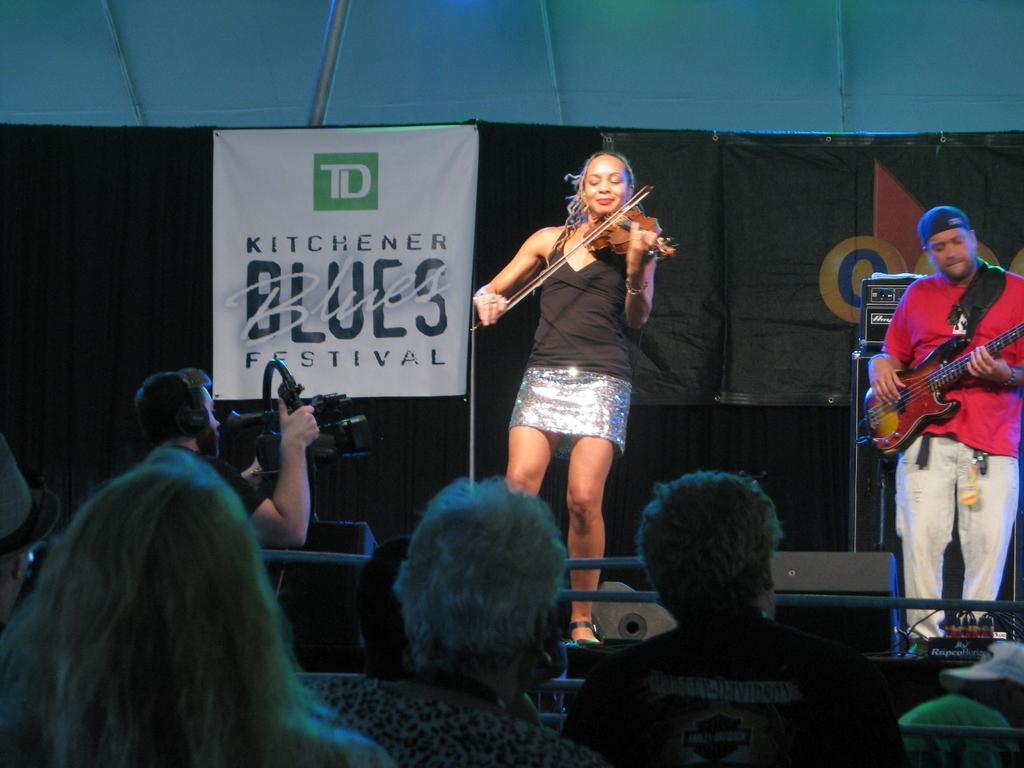Please provide a concise description of this image. In this image I can see two people are standing and playing the musical instruments. One person is wearing the black dress and another with red. In front of them there are group of people and one person is holding the camera. In the back there is a banner and the black curtain and also a sound box. 